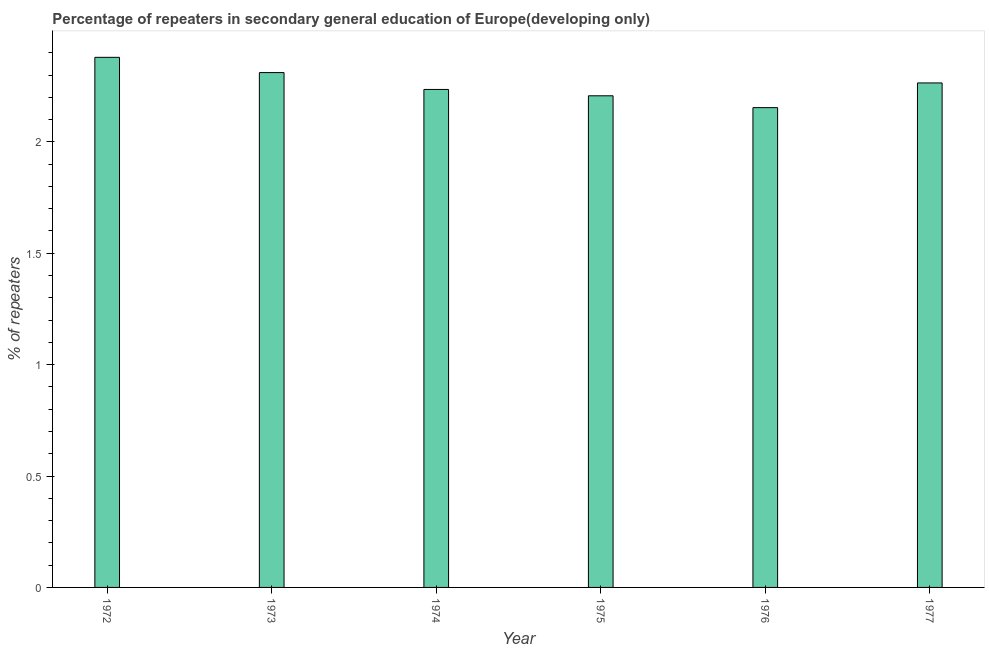Does the graph contain any zero values?
Your response must be concise. No. What is the title of the graph?
Your response must be concise. Percentage of repeaters in secondary general education of Europe(developing only). What is the label or title of the Y-axis?
Your answer should be compact. % of repeaters. What is the percentage of repeaters in 1974?
Your response must be concise. 2.24. Across all years, what is the maximum percentage of repeaters?
Offer a very short reply. 2.38. Across all years, what is the minimum percentage of repeaters?
Keep it short and to the point. 2.15. In which year was the percentage of repeaters maximum?
Make the answer very short. 1972. In which year was the percentage of repeaters minimum?
Ensure brevity in your answer.  1976. What is the sum of the percentage of repeaters?
Provide a short and direct response. 13.55. What is the difference between the percentage of repeaters in 1972 and 1976?
Keep it short and to the point. 0.23. What is the average percentage of repeaters per year?
Your answer should be compact. 2.26. What is the median percentage of repeaters?
Offer a very short reply. 2.25. Is the percentage of repeaters in 1972 less than that in 1973?
Give a very brief answer. No. What is the difference between the highest and the second highest percentage of repeaters?
Your answer should be very brief. 0.07. What is the difference between the highest and the lowest percentage of repeaters?
Your answer should be very brief. 0.23. In how many years, is the percentage of repeaters greater than the average percentage of repeaters taken over all years?
Give a very brief answer. 3. How many bars are there?
Keep it short and to the point. 6. How many years are there in the graph?
Keep it short and to the point. 6. What is the difference between two consecutive major ticks on the Y-axis?
Keep it short and to the point. 0.5. Are the values on the major ticks of Y-axis written in scientific E-notation?
Provide a succinct answer. No. What is the % of repeaters of 1972?
Offer a terse response. 2.38. What is the % of repeaters of 1973?
Make the answer very short. 2.31. What is the % of repeaters of 1974?
Keep it short and to the point. 2.24. What is the % of repeaters in 1975?
Offer a very short reply. 2.21. What is the % of repeaters of 1976?
Make the answer very short. 2.15. What is the % of repeaters in 1977?
Make the answer very short. 2.26. What is the difference between the % of repeaters in 1972 and 1973?
Ensure brevity in your answer.  0.07. What is the difference between the % of repeaters in 1972 and 1974?
Make the answer very short. 0.14. What is the difference between the % of repeaters in 1972 and 1975?
Your response must be concise. 0.17. What is the difference between the % of repeaters in 1972 and 1976?
Provide a short and direct response. 0.23. What is the difference between the % of repeaters in 1972 and 1977?
Offer a terse response. 0.11. What is the difference between the % of repeaters in 1973 and 1974?
Give a very brief answer. 0.08. What is the difference between the % of repeaters in 1973 and 1975?
Provide a succinct answer. 0.1. What is the difference between the % of repeaters in 1973 and 1976?
Ensure brevity in your answer.  0.16. What is the difference between the % of repeaters in 1973 and 1977?
Offer a terse response. 0.05. What is the difference between the % of repeaters in 1974 and 1975?
Make the answer very short. 0.03. What is the difference between the % of repeaters in 1974 and 1976?
Provide a succinct answer. 0.08. What is the difference between the % of repeaters in 1974 and 1977?
Offer a terse response. -0.03. What is the difference between the % of repeaters in 1975 and 1976?
Your answer should be very brief. 0.05. What is the difference between the % of repeaters in 1975 and 1977?
Keep it short and to the point. -0.06. What is the difference between the % of repeaters in 1976 and 1977?
Keep it short and to the point. -0.11. What is the ratio of the % of repeaters in 1972 to that in 1973?
Give a very brief answer. 1.03. What is the ratio of the % of repeaters in 1972 to that in 1974?
Your answer should be compact. 1.06. What is the ratio of the % of repeaters in 1972 to that in 1975?
Your response must be concise. 1.08. What is the ratio of the % of repeaters in 1972 to that in 1976?
Provide a short and direct response. 1.1. What is the ratio of the % of repeaters in 1972 to that in 1977?
Give a very brief answer. 1.05. What is the ratio of the % of repeaters in 1973 to that in 1974?
Provide a succinct answer. 1.03. What is the ratio of the % of repeaters in 1973 to that in 1975?
Offer a terse response. 1.05. What is the ratio of the % of repeaters in 1973 to that in 1976?
Offer a very short reply. 1.07. What is the ratio of the % of repeaters in 1974 to that in 1976?
Your answer should be very brief. 1.04. What is the ratio of the % of repeaters in 1974 to that in 1977?
Provide a short and direct response. 0.99. What is the ratio of the % of repeaters in 1976 to that in 1977?
Your response must be concise. 0.95. 